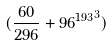Convert formula to latex. <formula><loc_0><loc_0><loc_500><loc_500>( \frac { 6 0 } { 2 9 6 } + { 9 6 ^ { 1 9 3 } } ^ { 3 } )</formula> 